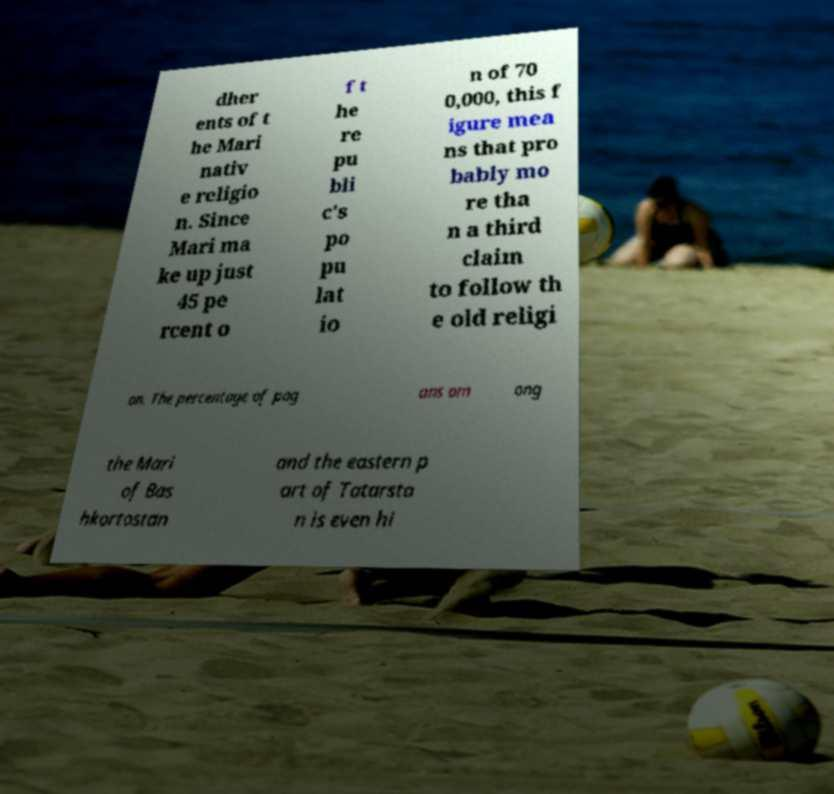Please identify and transcribe the text found in this image. dher ents of t he Mari nativ e religio n. Since Mari ma ke up just 45 pe rcent o f t he re pu bli c's po pu lat io n of 70 0,000, this f igure mea ns that pro bably mo re tha n a third claim to follow th e old religi on. The percentage of pag ans am ong the Mari of Bas hkortostan and the eastern p art of Tatarsta n is even hi 